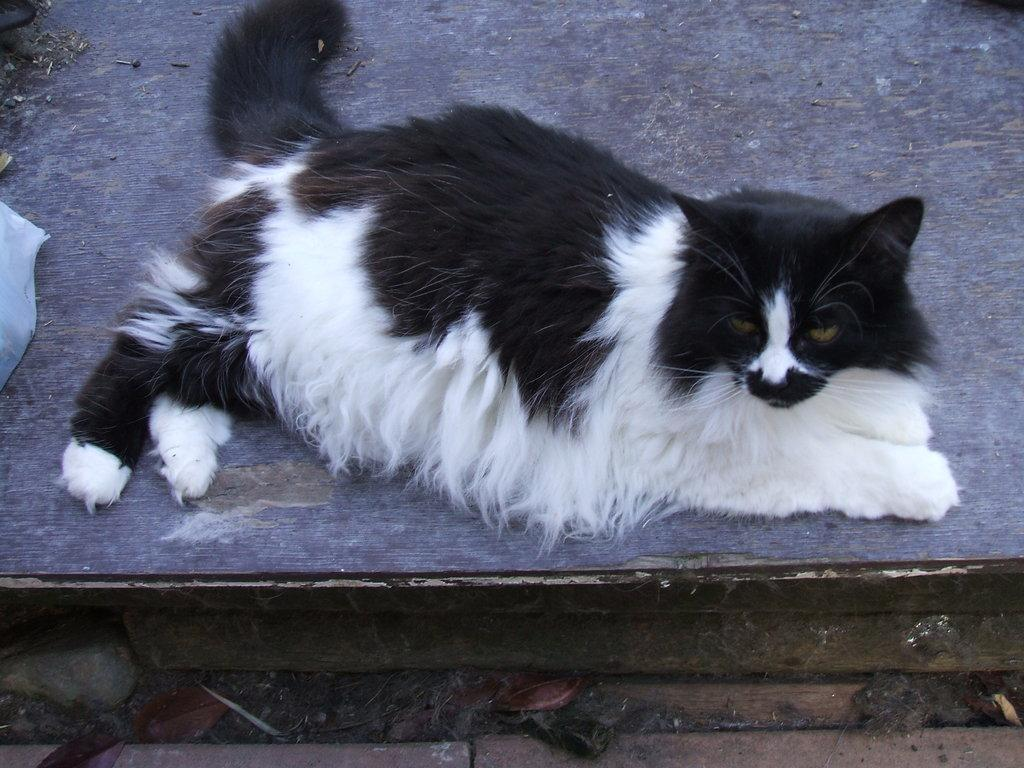What type of animal is in the image? There is a cat in the image. What is the cat sitting on in the image? The cat is on a wooden surface. What verse is the cat reciting in the image? There is no indication that the cat is reciting a verse in the image. 